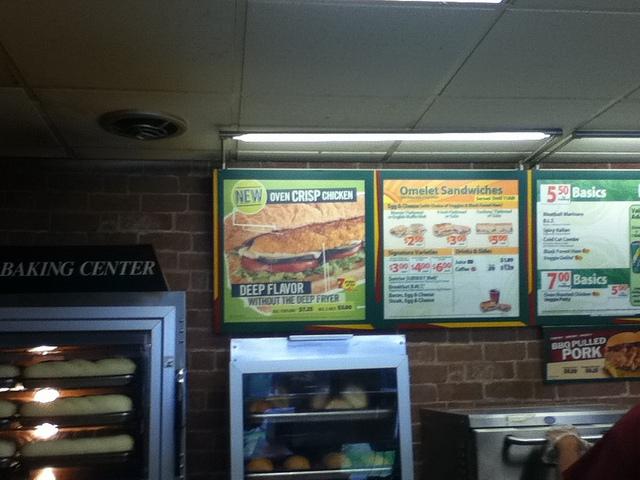Is this a fast food place?
Short answer required. Yes. What kind of building is in the picture?
Give a very brief answer. Restaurant. Can the bread be toasted?
Write a very short answer. Yes. What kind of store is this?
Answer briefly. Subway. Would these be good with coffee or tea?
Keep it brief. Yes. What is in the baking center?
Write a very short answer. Bread. 